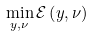Convert formula to latex. <formula><loc_0><loc_0><loc_500><loc_500>\min _ { y , \nu } \mathcal { E } \left ( y , \nu \right )</formula> 